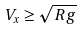Convert formula to latex. <formula><loc_0><loc_0><loc_500><loc_500>V _ { x } \geq \sqrt { R g }</formula> 